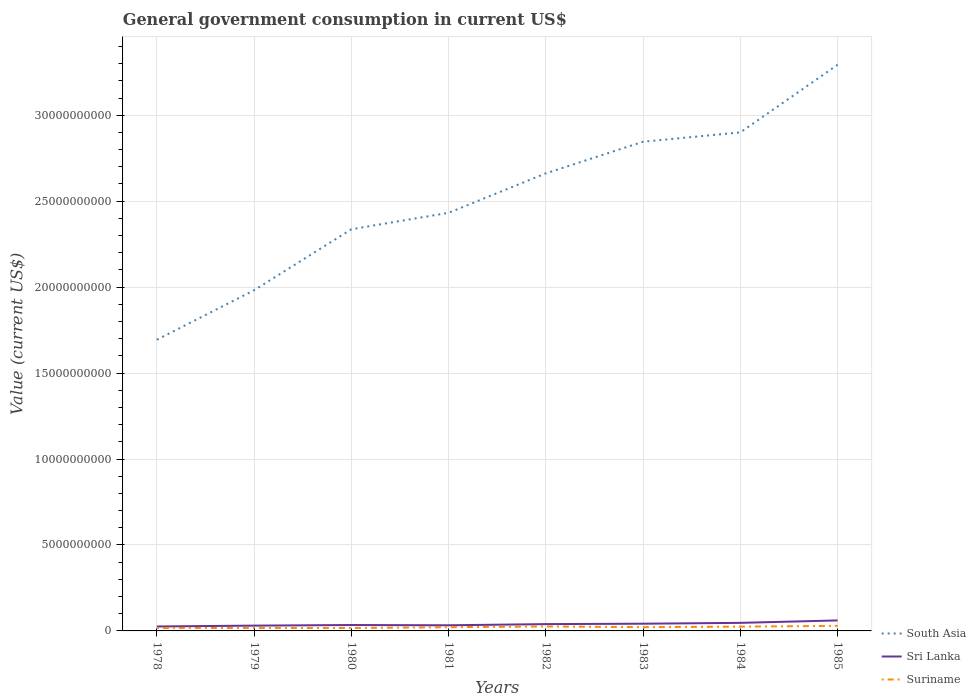How many different coloured lines are there?
Offer a terse response. 3. Does the line corresponding to Sri Lanka intersect with the line corresponding to South Asia?
Offer a terse response. No. Is the number of lines equal to the number of legend labels?
Ensure brevity in your answer.  Yes. Across all years, what is the maximum government conusmption in Suriname?
Your answer should be very brief. 1.68e+08. In which year was the government conusmption in Sri Lanka maximum?
Provide a succinct answer. 1978. What is the total government conusmption in Sri Lanka in the graph?
Provide a succinct answer. -1.96e+07. What is the difference between the highest and the second highest government conusmption in Suriname?
Your answer should be compact. 1.27e+08. How many lines are there?
Ensure brevity in your answer.  3. How many years are there in the graph?
Provide a succinct answer. 8. What is the difference between two consecutive major ticks on the Y-axis?
Give a very brief answer. 5.00e+09. Where does the legend appear in the graph?
Provide a succinct answer. Bottom right. How are the legend labels stacked?
Offer a very short reply. Vertical. What is the title of the graph?
Provide a succinct answer. General government consumption in current US$. Does "Benin" appear as one of the legend labels in the graph?
Offer a very short reply. No. What is the label or title of the Y-axis?
Offer a terse response. Value (current US$). What is the Value (current US$) of South Asia in 1978?
Provide a short and direct response. 1.69e+1. What is the Value (current US$) in Sri Lanka in 1978?
Your answer should be compact. 2.59e+08. What is the Value (current US$) in Suriname in 1978?
Offer a very short reply. 1.68e+08. What is the Value (current US$) in South Asia in 1979?
Make the answer very short. 1.98e+1. What is the Value (current US$) of Sri Lanka in 1979?
Give a very brief answer. 3.08e+08. What is the Value (current US$) in Suriname in 1979?
Offer a terse response. 1.72e+08. What is the Value (current US$) of South Asia in 1980?
Make the answer very short. 2.34e+1. What is the Value (current US$) of Sri Lanka in 1980?
Provide a succinct answer. 3.44e+08. What is the Value (current US$) in Suriname in 1980?
Your response must be concise. 1.70e+08. What is the Value (current US$) of South Asia in 1981?
Offer a very short reply. 2.43e+1. What is the Value (current US$) in Sri Lanka in 1981?
Make the answer very short. 3.28e+08. What is the Value (current US$) of Suriname in 1981?
Keep it short and to the point. 2.16e+08. What is the Value (current US$) in South Asia in 1982?
Your answer should be compact. 2.66e+1. What is the Value (current US$) of Sri Lanka in 1982?
Provide a short and direct response. 3.96e+08. What is the Value (current US$) in Suriname in 1982?
Offer a terse response. 2.60e+08. What is the Value (current US$) of South Asia in 1983?
Ensure brevity in your answer.  2.85e+1. What is the Value (current US$) in Sri Lanka in 1983?
Offer a very short reply. 4.20e+08. What is the Value (current US$) of Suriname in 1983?
Make the answer very short. 2.19e+08. What is the Value (current US$) in South Asia in 1984?
Give a very brief answer. 2.90e+1. What is the Value (current US$) in Sri Lanka in 1984?
Offer a very short reply. 4.69e+08. What is the Value (current US$) in Suriname in 1984?
Make the answer very short. 2.49e+08. What is the Value (current US$) in South Asia in 1985?
Offer a very short reply. 3.29e+1. What is the Value (current US$) in Sri Lanka in 1985?
Offer a terse response. 6.11e+08. What is the Value (current US$) of Suriname in 1985?
Make the answer very short. 2.94e+08. Across all years, what is the maximum Value (current US$) in South Asia?
Ensure brevity in your answer.  3.29e+1. Across all years, what is the maximum Value (current US$) in Sri Lanka?
Give a very brief answer. 6.11e+08. Across all years, what is the maximum Value (current US$) in Suriname?
Your answer should be compact. 2.94e+08. Across all years, what is the minimum Value (current US$) of South Asia?
Ensure brevity in your answer.  1.69e+1. Across all years, what is the minimum Value (current US$) in Sri Lanka?
Your answer should be very brief. 2.59e+08. Across all years, what is the minimum Value (current US$) in Suriname?
Offer a terse response. 1.68e+08. What is the total Value (current US$) in South Asia in the graph?
Your response must be concise. 2.01e+11. What is the total Value (current US$) of Sri Lanka in the graph?
Your answer should be very brief. 3.14e+09. What is the total Value (current US$) in Suriname in the graph?
Offer a terse response. 1.75e+09. What is the difference between the Value (current US$) in South Asia in 1978 and that in 1979?
Offer a terse response. -2.88e+09. What is the difference between the Value (current US$) of Sri Lanka in 1978 and that in 1979?
Your response must be concise. -4.92e+07. What is the difference between the Value (current US$) in Suriname in 1978 and that in 1979?
Make the answer very short. -4.00e+06. What is the difference between the Value (current US$) in South Asia in 1978 and that in 1980?
Provide a succinct answer. -6.43e+09. What is the difference between the Value (current US$) of Sri Lanka in 1978 and that in 1980?
Keep it short and to the point. -8.49e+07. What is the difference between the Value (current US$) in Suriname in 1978 and that in 1980?
Keep it short and to the point. -2.00e+06. What is the difference between the Value (current US$) in South Asia in 1978 and that in 1981?
Offer a terse response. -7.38e+09. What is the difference between the Value (current US$) in Sri Lanka in 1978 and that in 1981?
Your answer should be very brief. -6.88e+07. What is the difference between the Value (current US$) in Suriname in 1978 and that in 1981?
Provide a short and direct response. -4.80e+07. What is the difference between the Value (current US$) of South Asia in 1978 and that in 1982?
Provide a short and direct response. -9.68e+09. What is the difference between the Value (current US$) in Sri Lanka in 1978 and that in 1982?
Give a very brief answer. -1.37e+08. What is the difference between the Value (current US$) of Suriname in 1978 and that in 1982?
Your answer should be compact. -9.25e+07. What is the difference between the Value (current US$) in South Asia in 1978 and that in 1983?
Offer a very short reply. -1.15e+1. What is the difference between the Value (current US$) of Sri Lanka in 1978 and that in 1983?
Ensure brevity in your answer.  -1.61e+08. What is the difference between the Value (current US$) of Suriname in 1978 and that in 1983?
Offer a very short reply. -5.11e+07. What is the difference between the Value (current US$) of South Asia in 1978 and that in 1984?
Your answer should be compact. -1.21e+1. What is the difference between the Value (current US$) of Sri Lanka in 1978 and that in 1984?
Provide a succinct answer. -2.10e+08. What is the difference between the Value (current US$) of Suriname in 1978 and that in 1984?
Make the answer very short. -8.19e+07. What is the difference between the Value (current US$) of South Asia in 1978 and that in 1985?
Provide a short and direct response. -1.60e+1. What is the difference between the Value (current US$) in Sri Lanka in 1978 and that in 1985?
Your answer should be compact. -3.52e+08. What is the difference between the Value (current US$) in Suriname in 1978 and that in 1985?
Ensure brevity in your answer.  -1.27e+08. What is the difference between the Value (current US$) of South Asia in 1979 and that in 1980?
Offer a terse response. -3.55e+09. What is the difference between the Value (current US$) of Sri Lanka in 1979 and that in 1980?
Ensure brevity in your answer.  -3.58e+07. What is the difference between the Value (current US$) of South Asia in 1979 and that in 1981?
Keep it short and to the point. -4.50e+09. What is the difference between the Value (current US$) of Sri Lanka in 1979 and that in 1981?
Make the answer very short. -1.96e+07. What is the difference between the Value (current US$) of Suriname in 1979 and that in 1981?
Make the answer very short. -4.40e+07. What is the difference between the Value (current US$) of South Asia in 1979 and that in 1982?
Your answer should be very brief. -6.80e+09. What is the difference between the Value (current US$) of Sri Lanka in 1979 and that in 1982?
Keep it short and to the point. -8.79e+07. What is the difference between the Value (current US$) in Suriname in 1979 and that in 1982?
Give a very brief answer. -8.85e+07. What is the difference between the Value (current US$) in South Asia in 1979 and that in 1983?
Give a very brief answer. -8.64e+09. What is the difference between the Value (current US$) in Sri Lanka in 1979 and that in 1983?
Offer a very short reply. -1.12e+08. What is the difference between the Value (current US$) of Suriname in 1979 and that in 1983?
Keep it short and to the point. -4.71e+07. What is the difference between the Value (current US$) in South Asia in 1979 and that in 1984?
Your response must be concise. -9.18e+09. What is the difference between the Value (current US$) in Sri Lanka in 1979 and that in 1984?
Make the answer very short. -1.61e+08. What is the difference between the Value (current US$) of Suriname in 1979 and that in 1984?
Your answer should be compact. -7.79e+07. What is the difference between the Value (current US$) of South Asia in 1979 and that in 1985?
Your response must be concise. -1.31e+1. What is the difference between the Value (current US$) in Sri Lanka in 1979 and that in 1985?
Offer a terse response. -3.03e+08. What is the difference between the Value (current US$) of Suriname in 1979 and that in 1985?
Make the answer very short. -1.23e+08. What is the difference between the Value (current US$) in South Asia in 1980 and that in 1981?
Your response must be concise. -9.56e+08. What is the difference between the Value (current US$) in Sri Lanka in 1980 and that in 1981?
Provide a short and direct response. 1.61e+07. What is the difference between the Value (current US$) of Suriname in 1980 and that in 1981?
Ensure brevity in your answer.  -4.60e+07. What is the difference between the Value (current US$) of South Asia in 1980 and that in 1982?
Provide a short and direct response. -3.25e+09. What is the difference between the Value (current US$) of Sri Lanka in 1980 and that in 1982?
Offer a very short reply. -5.21e+07. What is the difference between the Value (current US$) in Suriname in 1980 and that in 1982?
Provide a short and direct response. -9.05e+07. What is the difference between the Value (current US$) in South Asia in 1980 and that in 1983?
Make the answer very short. -5.09e+09. What is the difference between the Value (current US$) in Sri Lanka in 1980 and that in 1983?
Your response must be concise. -7.64e+07. What is the difference between the Value (current US$) in Suriname in 1980 and that in 1983?
Your answer should be compact. -4.91e+07. What is the difference between the Value (current US$) in South Asia in 1980 and that in 1984?
Your answer should be very brief. -5.63e+09. What is the difference between the Value (current US$) in Sri Lanka in 1980 and that in 1984?
Keep it short and to the point. -1.25e+08. What is the difference between the Value (current US$) in Suriname in 1980 and that in 1984?
Your answer should be compact. -7.99e+07. What is the difference between the Value (current US$) in South Asia in 1980 and that in 1985?
Ensure brevity in your answer.  -9.57e+09. What is the difference between the Value (current US$) in Sri Lanka in 1980 and that in 1985?
Offer a terse response. -2.67e+08. What is the difference between the Value (current US$) of Suriname in 1980 and that in 1985?
Your answer should be very brief. -1.25e+08. What is the difference between the Value (current US$) in South Asia in 1981 and that in 1982?
Provide a succinct answer. -2.30e+09. What is the difference between the Value (current US$) in Sri Lanka in 1981 and that in 1982?
Give a very brief answer. -6.83e+07. What is the difference between the Value (current US$) in Suriname in 1981 and that in 1982?
Ensure brevity in your answer.  -4.45e+07. What is the difference between the Value (current US$) in South Asia in 1981 and that in 1983?
Give a very brief answer. -4.14e+09. What is the difference between the Value (current US$) in Sri Lanka in 1981 and that in 1983?
Your response must be concise. -9.25e+07. What is the difference between the Value (current US$) in Suriname in 1981 and that in 1983?
Your answer should be compact. -3.10e+06. What is the difference between the Value (current US$) of South Asia in 1981 and that in 1984?
Your answer should be compact. -4.68e+09. What is the difference between the Value (current US$) of Sri Lanka in 1981 and that in 1984?
Your response must be concise. -1.41e+08. What is the difference between the Value (current US$) of Suriname in 1981 and that in 1984?
Give a very brief answer. -3.39e+07. What is the difference between the Value (current US$) in South Asia in 1981 and that in 1985?
Your response must be concise. -8.61e+09. What is the difference between the Value (current US$) in Sri Lanka in 1981 and that in 1985?
Your response must be concise. -2.83e+08. What is the difference between the Value (current US$) of Suriname in 1981 and that in 1985?
Provide a short and direct response. -7.88e+07. What is the difference between the Value (current US$) in South Asia in 1982 and that in 1983?
Make the answer very short. -1.84e+09. What is the difference between the Value (current US$) of Sri Lanka in 1982 and that in 1983?
Provide a short and direct response. -2.42e+07. What is the difference between the Value (current US$) in Suriname in 1982 and that in 1983?
Your response must be concise. 4.14e+07. What is the difference between the Value (current US$) in South Asia in 1982 and that in 1984?
Give a very brief answer. -2.38e+09. What is the difference between the Value (current US$) in Sri Lanka in 1982 and that in 1984?
Your answer should be very brief. -7.31e+07. What is the difference between the Value (current US$) in Suriname in 1982 and that in 1984?
Make the answer very short. 1.06e+07. What is the difference between the Value (current US$) of South Asia in 1982 and that in 1985?
Your response must be concise. -6.32e+09. What is the difference between the Value (current US$) in Sri Lanka in 1982 and that in 1985?
Ensure brevity in your answer.  -2.15e+08. What is the difference between the Value (current US$) of Suriname in 1982 and that in 1985?
Your answer should be very brief. -3.42e+07. What is the difference between the Value (current US$) in South Asia in 1983 and that in 1984?
Your answer should be compact. -5.43e+08. What is the difference between the Value (current US$) in Sri Lanka in 1983 and that in 1984?
Your response must be concise. -4.89e+07. What is the difference between the Value (current US$) of Suriname in 1983 and that in 1984?
Make the answer very short. -3.08e+07. What is the difference between the Value (current US$) in South Asia in 1983 and that in 1985?
Your response must be concise. -4.48e+09. What is the difference between the Value (current US$) in Sri Lanka in 1983 and that in 1985?
Your response must be concise. -1.91e+08. What is the difference between the Value (current US$) in Suriname in 1983 and that in 1985?
Your answer should be compact. -7.56e+07. What is the difference between the Value (current US$) of South Asia in 1984 and that in 1985?
Provide a short and direct response. -3.93e+09. What is the difference between the Value (current US$) in Sri Lanka in 1984 and that in 1985?
Keep it short and to the point. -1.42e+08. What is the difference between the Value (current US$) in Suriname in 1984 and that in 1985?
Your answer should be compact. -4.48e+07. What is the difference between the Value (current US$) of South Asia in 1978 and the Value (current US$) of Sri Lanka in 1979?
Ensure brevity in your answer.  1.66e+1. What is the difference between the Value (current US$) in South Asia in 1978 and the Value (current US$) in Suriname in 1979?
Ensure brevity in your answer.  1.68e+1. What is the difference between the Value (current US$) of Sri Lanka in 1978 and the Value (current US$) of Suriname in 1979?
Provide a succinct answer. 8.75e+07. What is the difference between the Value (current US$) of South Asia in 1978 and the Value (current US$) of Sri Lanka in 1980?
Your answer should be compact. 1.66e+1. What is the difference between the Value (current US$) in South Asia in 1978 and the Value (current US$) in Suriname in 1980?
Offer a terse response. 1.68e+1. What is the difference between the Value (current US$) in Sri Lanka in 1978 and the Value (current US$) in Suriname in 1980?
Your answer should be compact. 8.95e+07. What is the difference between the Value (current US$) of South Asia in 1978 and the Value (current US$) of Sri Lanka in 1981?
Give a very brief answer. 1.66e+1. What is the difference between the Value (current US$) in South Asia in 1978 and the Value (current US$) in Suriname in 1981?
Your answer should be compact. 1.67e+1. What is the difference between the Value (current US$) of Sri Lanka in 1978 and the Value (current US$) of Suriname in 1981?
Keep it short and to the point. 4.35e+07. What is the difference between the Value (current US$) in South Asia in 1978 and the Value (current US$) in Sri Lanka in 1982?
Your answer should be compact. 1.65e+1. What is the difference between the Value (current US$) of South Asia in 1978 and the Value (current US$) of Suriname in 1982?
Provide a short and direct response. 1.67e+1. What is the difference between the Value (current US$) in Sri Lanka in 1978 and the Value (current US$) in Suriname in 1982?
Your response must be concise. -9.99e+05. What is the difference between the Value (current US$) of South Asia in 1978 and the Value (current US$) of Sri Lanka in 1983?
Offer a very short reply. 1.65e+1. What is the difference between the Value (current US$) of South Asia in 1978 and the Value (current US$) of Suriname in 1983?
Ensure brevity in your answer.  1.67e+1. What is the difference between the Value (current US$) of Sri Lanka in 1978 and the Value (current US$) of Suriname in 1983?
Offer a very short reply. 4.04e+07. What is the difference between the Value (current US$) in South Asia in 1978 and the Value (current US$) in Sri Lanka in 1984?
Your response must be concise. 1.65e+1. What is the difference between the Value (current US$) of South Asia in 1978 and the Value (current US$) of Suriname in 1984?
Provide a short and direct response. 1.67e+1. What is the difference between the Value (current US$) of Sri Lanka in 1978 and the Value (current US$) of Suriname in 1984?
Provide a succinct answer. 9.60e+06. What is the difference between the Value (current US$) of South Asia in 1978 and the Value (current US$) of Sri Lanka in 1985?
Provide a short and direct response. 1.63e+1. What is the difference between the Value (current US$) of South Asia in 1978 and the Value (current US$) of Suriname in 1985?
Make the answer very short. 1.66e+1. What is the difference between the Value (current US$) in Sri Lanka in 1978 and the Value (current US$) in Suriname in 1985?
Your response must be concise. -3.52e+07. What is the difference between the Value (current US$) of South Asia in 1979 and the Value (current US$) of Sri Lanka in 1980?
Make the answer very short. 1.95e+1. What is the difference between the Value (current US$) of South Asia in 1979 and the Value (current US$) of Suriname in 1980?
Your answer should be very brief. 1.97e+1. What is the difference between the Value (current US$) in Sri Lanka in 1979 and the Value (current US$) in Suriname in 1980?
Make the answer very short. 1.39e+08. What is the difference between the Value (current US$) of South Asia in 1979 and the Value (current US$) of Sri Lanka in 1981?
Your answer should be very brief. 1.95e+1. What is the difference between the Value (current US$) of South Asia in 1979 and the Value (current US$) of Suriname in 1981?
Give a very brief answer. 1.96e+1. What is the difference between the Value (current US$) in Sri Lanka in 1979 and the Value (current US$) in Suriname in 1981?
Your answer should be very brief. 9.27e+07. What is the difference between the Value (current US$) of South Asia in 1979 and the Value (current US$) of Sri Lanka in 1982?
Give a very brief answer. 1.94e+1. What is the difference between the Value (current US$) of South Asia in 1979 and the Value (current US$) of Suriname in 1982?
Ensure brevity in your answer.  1.96e+1. What is the difference between the Value (current US$) of Sri Lanka in 1979 and the Value (current US$) of Suriname in 1982?
Make the answer very short. 4.82e+07. What is the difference between the Value (current US$) in South Asia in 1979 and the Value (current US$) in Sri Lanka in 1983?
Keep it short and to the point. 1.94e+1. What is the difference between the Value (current US$) of South Asia in 1979 and the Value (current US$) of Suriname in 1983?
Make the answer very short. 1.96e+1. What is the difference between the Value (current US$) in Sri Lanka in 1979 and the Value (current US$) in Suriname in 1983?
Your answer should be compact. 8.96e+07. What is the difference between the Value (current US$) of South Asia in 1979 and the Value (current US$) of Sri Lanka in 1984?
Keep it short and to the point. 1.94e+1. What is the difference between the Value (current US$) in South Asia in 1979 and the Value (current US$) in Suriname in 1984?
Your answer should be very brief. 1.96e+1. What is the difference between the Value (current US$) of Sri Lanka in 1979 and the Value (current US$) of Suriname in 1984?
Offer a terse response. 5.88e+07. What is the difference between the Value (current US$) in South Asia in 1979 and the Value (current US$) in Sri Lanka in 1985?
Make the answer very short. 1.92e+1. What is the difference between the Value (current US$) of South Asia in 1979 and the Value (current US$) of Suriname in 1985?
Give a very brief answer. 1.95e+1. What is the difference between the Value (current US$) in Sri Lanka in 1979 and the Value (current US$) in Suriname in 1985?
Your answer should be compact. 1.39e+07. What is the difference between the Value (current US$) of South Asia in 1980 and the Value (current US$) of Sri Lanka in 1981?
Your answer should be compact. 2.30e+1. What is the difference between the Value (current US$) in South Asia in 1980 and the Value (current US$) in Suriname in 1981?
Keep it short and to the point. 2.32e+1. What is the difference between the Value (current US$) of Sri Lanka in 1980 and the Value (current US$) of Suriname in 1981?
Give a very brief answer. 1.28e+08. What is the difference between the Value (current US$) in South Asia in 1980 and the Value (current US$) in Sri Lanka in 1982?
Ensure brevity in your answer.  2.30e+1. What is the difference between the Value (current US$) in South Asia in 1980 and the Value (current US$) in Suriname in 1982?
Your response must be concise. 2.31e+1. What is the difference between the Value (current US$) in Sri Lanka in 1980 and the Value (current US$) in Suriname in 1982?
Make the answer very short. 8.39e+07. What is the difference between the Value (current US$) in South Asia in 1980 and the Value (current US$) in Sri Lanka in 1983?
Keep it short and to the point. 2.29e+1. What is the difference between the Value (current US$) of South Asia in 1980 and the Value (current US$) of Suriname in 1983?
Your answer should be very brief. 2.31e+1. What is the difference between the Value (current US$) in Sri Lanka in 1980 and the Value (current US$) in Suriname in 1983?
Give a very brief answer. 1.25e+08. What is the difference between the Value (current US$) in South Asia in 1980 and the Value (current US$) in Sri Lanka in 1984?
Your answer should be compact. 2.29e+1. What is the difference between the Value (current US$) in South Asia in 1980 and the Value (current US$) in Suriname in 1984?
Your answer should be compact. 2.31e+1. What is the difference between the Value (current US$) of Sri Lanka in 1980 and the Value (current US$) of Suriname in 1984?
Your answer should be very brief. 9.45e+07. What is the difference between the Value (current US$) in South Asia in 1980 and the Value (current US$) in Sri Lanka in 1985?
Offer a terse response. 2.28e+1. What is the difference between the Value (current US$) of South Asia in 1980 and the Value (current US$) of Suriname in 1985?
Give a very brief answer. 2.31e+1. What is the difference between the Value (current US$) of Sri Lanka in 1980 and the Value (current US$) of Suriname in 1985?
Make the answer very short. 4.97e+07. What is the difference between the Value (current US$) of South Asia in 1981 and the Value (current US$) of Sri Lanka in 1982?
Your answer should be very brief. 2.39e+1. What is the difference between the Value (current US$) in South Asia in 1981 and the Value (current US$) in Suriname in 1982?
Offer a terse response. 2.41e+1. What is the difference between the Value (current US$) of Sri Lanka in 1981 and the Value (current US$) of Suriname in 1982?
Your response must be concise. 6.78e+07. What is the difference between the Value (current US$) of South Asia in 1981 and the Value (current US$) of Sri Lanka in 1983?
Your answer should be very brief. 2.39e+1. What is the difference between the Value (current US$) in South Asia in 1981 and the Value (current US$) in Suriname in 1983?
Keep it short and to the point. 2.41e+1. What is the difference between the Value (current US$) in Sri Lanka in 1981 and the Value (current US$) in Suriname in 1983?
Provide a succinct answer. 1.09e+08. What is the difference between the Value (current US$) in South Asia in 1981 and the Value (current US$) in Sri Lanka in 1984?
Offer a very short reply. 2.39e+1. What is the difference between the Value (current US$) of South Asia in 1981 and the Value (current US$) of Suriname in 1984?
Your response must be concise. 2.41e+1. What is the difference between the Value (current US$) in Sri Lanka in 1981 and the Value (current US$) in Suriname in 1984?
Provide a succinct answer. 7.84e+07. What is the difference between the Value (current US$) in South Asia in 1981 and the Value (current US$) in Sri Lanka in 1985?
Keep it short and to the point. 2.37e+1. What is the difference between the Value (current US$) in South Asia in 1981 and the Value (current US$) in Suriname in 1985?
Ensure brevity in your answer.  2.40e+1. What is the difference between the Value (current US$) in Sri Lanka in 1981 and the Value (current US$) in Suriname in 1985?
Ensure brevity in your answer.  3.35e+07. What is the difference between the Value (current US$) in South Asia in 1982 and the Value (current US$) in Sri Lanka in 1983?
Provide a short and direct response. 2.62e+1. What is the difference between the Value (current US$) of South Asia in 1982 and the Value (current US$) of Suriname in 1983?
Offer a terse response. 2.64e+1. What is the difference between the Value (current US$) in Sri Lanka in 1982 and the Value (current US$) in Suriname in 1983?
Provide a short and direct response. 1.77e+08. What is the difference between the Value (current US$) of South Asia in 1982 and the Value (current US$) of Sri Lanka in 1984?
Your answer should be very brief. 2.61e+1. What is the difference between the Value (current US$) of South Asia in 1982 and the Value (current US$) of Suriname in 1984?
Provide a short and direct response. 2.64e+1. What is the difference between the Value (current US$) in Sri Lanka in 1982 and the Value (current US$) in Suriname in 1984?
Offer a very short reply. 1.47e+08. What is the difference between the Value (current US$) of South Asia in 1982 and the Value (current US$) of Sri Lanka in 1985?
Offer a terse response. 2.60e+1. What is the difference between the Value (current US$) in South Asia in 1982 and the Value (current US$) in Suriname in 1985?
Give a very brief answer. 2.63e+1. What is the difference between the Value (current US$) of Sri Lanka in 1982 and the Value (current US$) of Suriname in 1985?
Your answer should be very brief. 1.02e+08. What is the difference between the Value (current US$) of South Asia in 1983 and the Value (current US$) of Sri Lanka in 1984?
Your response must be concise. 2.80e+1. What is the difference between the Value (current US$) in South Asia in 1983 and the Value (current US$) in Suriname in 1984?
Provide a short and direct response. 2.82e+1. What is the difference between the Value (current US$) in Sri Lanka in 1983 and the Value (current US$) in Suriname in 1984?
Keep it short and to the point. 1.71e+08. What is the difference between the Value (current US$) of South Asia in 1983 and the Value (current US$) of Sri Lanka in 1985?
Make the answer very short. 2.78e+1. What is the difference between the Value (current US$) of South Asia in 1983 and the Value (current US$) of Suriname in 1985?
Your answer should be compact. 2.82e+1. What is the difference between the Value (current US$) of Sri Lanka in 1983 and the Value (current US$) of Suriname in 1985?
Provide a short and direct response. 1.26e+08. What is the difference between the Value (current US$) of South Asia in 1984 and the Value (current US$) of Sri Lanka in 1985?
Your response must be concise. 2.84e+1. What is the difference between the Value (current US$) of South Asia in 1984 and the Value (current US$) of Suriname in 1985?
Your answer should be compact. 2.87e+1. What is the difference between the Value (current US$) in Sri Lanka in 1984 and the Value (current US$) in Suriname in 1985?
Your answer should be compact. 1.75e+08. What is the average Value (current US$) in South Asia per year?
Offer a terse response. 2.52e+1. What is the average Value (current US$) of Sri Lanka per year?
Offer a terse response. 3.92e+08. What is the average Value (current US$) of Suriname per year?
Your answer should be very brief. 2.18e+08. In the year 1978, what is the difference between the Value (current US$) in South Asia and Value (current US$) in Sri Lanka?
Provide a short and direct response. 1.67e+1. In the year 1978, what is the difference between the Value (current US$) of South Asia and Value (current US$) of Suriname?
Provide a succinct answer. 1.68e+1. In the year 1978, what is the difference between the Value (current US$) in Sri Lanka and Value (current US$) in Suriname?
Provide a succinct answer. 9.15e+07. In the year 1979, what is the difference between the Value (current US$) in South Asia and Value (current US$) in Sri Lanka?
Provide a succinct answer. 1.95e+1. In the year 1979, what is the difference between the Value (current US$) in South Asia and Value (current US$) in Suriname?
Your response must be concise. 1.96e+1. In the year 1979, what is the difference between the Value (current US$) of Sri Lanka and Value (current US$) of Suriname?
Your answer should be compact. 1.37e+08. In the year 1980, what is the difference between the Value (current US$) of South Asia and Value (current US$) of Sri Lanka?
Provide a short and direct response. 2.30e+1. In the year 1980, what is the difference between the Value (current US$) of South Asia and Value (current US$) of Suriname?
Make the answer very short. 2.32e+1. In the year 1980, what is the difference between the Value (current US$) in Sri Lanka and Value (current US$) in Suriname?
Keep it short and to the point. 1.74e+08. In the year 1981, what is the difference between the Value (current US$) in South Asia and Value (current US$) in Sri Lanka?
Provide a short and direct response. 2.40e+1. In the year 1981, what is the difference between the Value (current US$) of South Asia and Value (current US$) of Suriname?
Provide a succinct answer. 2.41e+1. In the year 1981, what is the difference between the Value (current US$) in Sri Lanka and Value (current US$) in Suriname?
Your answer should be very brief. 1.12e+08. In the year 1982, what is the difference between the Value (current US$) of South Asia and Value (current US$) of Sri Lanka?
Make the answer very short. 2.62e+1. In the year 1982, what is the difference between the Value (current US$) in South Asia and Value (current US$) in Suriname?
Offer a very short reply. 2.64e+1. In the year 1982, what is the difference between the Value (current US$) in Sri Lanka and Value (current US$) in Suriname?
Give a very brief answer. 1.36e+08. In the year 1983, what is the difference between the Value (current US$) in South Asia and Value (current US$) in Sri Lanka?
Your answer should be very brief. 2.80e+1. In the year 1983, what is the difference between the Value (current US$) of South Asia and Value (current US$) of Suriname?
Ensure brevity in your answer.  2.82e+1. In the year 1983, what is the difference between the Value (current US$) of Sri Lanka and Value (current US$) of Suriname?
Your response must be concise. 2.02e+08. In the year 1984, what is the difference between the Value (current US$) in South Asia and Value (current US$) in Sri Lanka?
Give a very brief answer. 2.85e+1. In the year 1984, what is the difference between the Value (current US$) in South Asia and Value (current US$) in Suriname?
Provide a succinct answer. 2.88e+1. In the year 1984, what is the difference between the Value (current US$) in Sri Lanka and Value (current US$) in Suriname?
Your answer should be compact. 2.20e+08. In the year 1985, what is the difference between the Value (current US$) of South Asia and Value (current US$) of Sri Lanka?
Keep it short and to the point. 3.23e+1. In the year 1985, what is the difference between the Value (current US$) of South Asia and Value (current US$) of Suriname?
Offer a terse response. 3.26e+1. In the year 1985, what is the difference between the Value (current US$) in Sri Lanka and Value (current US$) in Suriname?
Keep it short and to the point. 3.17e+08. What is the ratio of the Value (current US$) of South Asia in 1978 to that in 1979?
Make the answer very short. 0.85. What is the ratio of the Value (current US$) in Sri Lanka in 1978 to that in 1979?
Your answer should be very brief. 0.84. What is the ratio of the Value (current US$) in Suriname in 1978 to that in 1979?
Your answer should be compact. 0.98. What is the ratio of the Value (current US$) of South Asia in 1978 to that in 1980?
Provide a short and direct response. 0.72. What is the ratio of the Value (current US$) in Sri Lanka in 1978 to that in 1980?
Make the answer very short. 0.75. What is the ratio of the Value (current US$) of South Asia in 1978 to that in 1981?
Give a very brief answer. 0.7. What is the ratio of the Value (current US$) in Sri Lanka in 1978 to that in 1981?
Make the answer very short. 0.79. What is the ratio of the Value (current US$) in Suriname in 1978 to that in 1981?
Make the answer very short. 0.78. What is the ratio of the Value (current US$) in South Asia in 1978 to that in 1982?
Give a very brief answer. 0.64. What is the ratio of the Value (current US$) of Sri Lanka in 1978 to that in 1982?
Ensure brevity in your answer.  0.65. What is the ratio of the Value (current US$) in Suriname in 1978 to that in 1982?
Ensure brevity in your answer.  0.64. What is the ratio of the Value (current US$) in South Asia in 1978 to that in 1983?
Provide a short and direct response. 0.6. What is the ratio of the Value (current US$) of Sri Lanka in 1978 to that in 1983?
Ensure brevity in your answer.  0.62. What is the ratio of the Value (current US$) in Suriname in 1978 to that in 1983?
Make the answer very short. 0.77. What is the ratio of the Value (current US$) of South Asia in 1978 to that in 1984?
Offer a terse response. 0.58. What is the ratio of the Value (current US$) in Sri Lanka in 1978 to that in 1984?
Your answer should be very brief. 0.55. What is the ratio of the Value (current US$) of Suriname in 1978 to that in 1984?
Your answer should be compact. 0.67. What is the ratio of the Value (current US$) of South Asia in 1978 to that in 1985?
Your answer should be very brief. 0.51. What is the ratio of the Value (current US$) of Sri Lanka in 1978 to that in 1985?
Your answer should be compact. 0.42. What is the ratio of the Value (current US$) of Suriname in 1978 to that in 1985?
Your answer should be very brief. 0.57. What is the ratio of the Value (current US$) in South Asia in 1979 to that in 1980?
Your answer should be very brief. 0.85. What is the ratio of the Value (current US$) of Sri Lanka in 1979 to that in 1980?
Your response must be concise. 0.9. What is the ratio of the Value (current US$) in Suriname in 1979 to that in 1980?
Your answer should be very brief. 1.01. What is the ratio of the Value (current US$) in South Asia in 1979 to that in 1981?
Provide a succinct answer. 0.81. What is the ratio of the Value (current US$) of Sri Lanka in 1979 to that in 1981?
Your response must be concise. 0.94. What is the ratio of the Value (current US$) of Suriname in 1979 to that in 1981?
Keep it short and to the point. 0.8. What is the ratio of the Value (current US$) of South Asia in 1979 to that in 1982?
Provide a succinct answer. 0.74. What is the ratio of the Value (current US$) of Sri Lanka in 1979 to that in 1982?
Your response must be concise. 0.78. What is the ratio of the Value (current US$) in Suriname in 1979 to that in 1982?
Your answer should be compact. 0.66. What is the ratio of the Value (current US$) in South Asia in 1979 to that in 1983?
Provide a succinct answer. 0.7. What is the ratio of the Value (current US$) of Sri Lanka in 1979 to that in 1983?
Provide a short and direct response. 0.73. What is the ratio of the Value (current US$) of Suriname in 1979 to that in 1983?
Make the answer very short. 0.78. What is the ratio of the Value (current US$) in South Asia in 1979 to that in 1984?
Your response must be concise. 0.68. What is the ratio of the Value (current US$) of Sri Lanka in 1979 to that in 1984?
Make the answer very short. 0.66. What is the ratio of the Value (current US$) of Suriname in 1979 to that in 1984?
Keep it short and to the point. 0.69. What is the ratio of the Value (current US$) of South Asia in 1979 to that in 1985?
Provide a short and direct response. 0.6. What is the ratio of the Value (current US$) of Sri Lanka in 1979 to that in 1985?
Ensure brevity in your answer.  0.5. What is the ratio of the Value (current US$) in Suriname in 1979 to that in 1985?
Offer a terse response. 0.58. What is the ratio of the Value (current US$) of South Asia in 1980 to that in 1981?
Keep it short and to the point. 0.96. What is the ratio of the Value (current US$) of Sri Lanka in 1980 to that in 1981?
Ensure brevity in your answer.  1.05. What is the ratio of the Value (current US$) in Suriname in 1980 to that in 1981?
Keep it short and to the point. 0.79. What is the ratio of the Value (current US$) in South Asia in 1980 to that in 1982?
Offer a very short reply. 0.88. What is the ratio of the Value (current US$) in Sri Lanka in 1980 to that in 1982?
Your answer should be compact. 0.87. What is the ratio of the Value (current US$) in Suriname in 1980 to that in 1982?
Make the answer very short. 0.65. What is the ratio of the Value (current US$) of South Asia in 1980 to that in 1983?
Give a very brief answer. 0.82. What is the ratio of the Value (current US$) of Sri Lanka in 1980 to that in 1983?
Your answer should be compact. 0.82. What is the ratio of the Value (current US$) in Suriname in 1980 to that in 1983?
Your answer should be very brief. 0.78. What is the ratio of the Value (current US$) of South Asia in 1980 to that in 1984?
Make the answer very short. 0.81. What is the ratio of the Value (current US$) of Sri Lanka in 1980 to that in 1984?
Make the answer very short. 0.73. What is the ratio of the Value (current US$) in Suriname in 1980 to that in 1984?
Give a very brief answer. 0.68. What is the ratio of the Value (current US$) in South Asia in 1980 to that in 1985?
Your answer should be compact. 0.71. What is the ratio of the Value (current US$) of Sri Lanka in 1980 to that in 1985?
Offer a terse response. 0.56. What is the ratio of the Value (current US$) of Suriname in 1980 to that in 1985?
Your response must be concise. 0.58. What is the ratio of the Value (current US$) in South Asia in 1981 to that in 1982?
Keep it short and to the point. 0.91. What is the ratio of the Value (current US$) of Sri Lanka in 1981 to that in 1982?
Provide a short and direct response. 0.83. What is the ratio of the Value (current US$) of Suriname in 1981 to that in 1982?
Provide a short and direct response. 0.83. What is the ratio of the Value (current US$) in South Asia in 1981 to that in 1983?
Provide a short and direct response. 0.85. What is the ratio of the Value (current US$) in Sri Lanka in 1981 to that in 1983?
Keep it short and to the point. 0.78. What is the ratio of the Value (current US$) of Suriname in 1981 to that in 1983?
Make the answer very short. 0.99. What is the ratio of the Value (current US$) of South Asia in 1981 to that in 1984?
Make the answer very short. 0.84. What is the ratio of the Value (current US$) in Sri Lanka in 1981 to that in 1984?
Keep it short and to the point. 0.7. What is the ratio of the Value (current US$) in Suriname in 1981 to that in 1984?
Provide a succinct answer. 0.86. What is the ratio of the Value (current US$) in South Asia in 1981 to that in 1985?
Offer a very short reply. 0.74. What is the ratio of the Value (current US$) of Sri Lanka in 1981 to that in 1985?
Make the answer very short. 0.54. What is the ratio of the Value (current US$) in Suriname in 1981 to that in 1985?
Give a very brief answer. 0.73. What is the ratio of the Value (current US$) in South Asia in 1982 to that in 1983?
Keep it short and to the point. 0.94. What is the ratio of the Value (current US$) in Sri Lanka in 1982 to that in 1983?
Offer a very short reply. 0.94. What is the ratio of the Value (current US$) in Suriname in 1982 to that in 1983?
Your answer should be compact. 1.19. What is the ratio of the Value (current US$) of South Asia in 1982 to that in 1984?
Your answer should be very brief. 0.92. What is the ratio of the Value (current US$) in Sri Lanka in 1982 to that in 1984?
Your response must be concise. 0.84. What is the ratio of the Value (current US$) in Suriname in 1982 to that in 1984?
Offer a very short reply. 1.04. What is the ratio of the Value (current US$) in South Asia in 1982 to that in 1985?
Your answer should be compact. 0.81. What is the ratio of the Value (current US$) of Sri Lanka in 1982 to that in 1985?
Your answer should be compact. 0.65. What is the ratio of the Value (current US$) of Suriname in 1982 to that in 1985?
Make the answer very short. 0.88. What is the ratio of the Value (current US$) in South Asia in 1983 to that in 1984?
Give a very brief answer. 0.98. What is the ratio of the Value (current US$) of Sri Lanka in 1983 to that in 1984?
Keep it short and to the point. 0.9. What is the ratio of the Value (current US$) in Suriname in 1983 to that in 1984?
Give a very brief answer. 0.88. What is the ratio of the Value (current US$) of South Asia in 1983 to that in 1985?
Offer a terse response. 0.86. What is the ratio of the Value (current US$) in Sri Lanka in 1983 to that in 1985?
Make the answer very short. 0.69. What is the ratio of the Value (current US$) of Suriname in 1983 to that in 1985?
Your answer should be very brief. 0.74. What is the ratio of the Value (current US$) of South Asia in 1984 to that in 1985?
Your answer should be compact. 0.88. What is the ratio of the Value (current US$) of Sri Lanka in 1984 to that in 1985?
Provide a short and direct response. 0.77. What is the ratio of the Value (current US$) of Suriname in 1984 to that in 1985?
Keep it short and to the point. 0.85. What is the difference between the highest and the second highest Value (current US$) in South Asia?
Provide a short and direct response. 3.93e+09. What is the difference between the highest and the second highest Value (current US$) of Sri Lanka?
Offer a very short reply. 1.42e+08. What is the difference between the highest and the second highest Value (current US$) in Suriname?
Your response must be concise. 3.42e+07. What is the difference between the highest and the lowest Value (current US$) of South Asia?
Provide a succinct answer. 1.60e+1. What is the difference between the highest and the lowest Value (current US$) in Sri Lanka?
Your answer should be compact. 3.52e+08. What is the difference between the highest and the lowest Value (current US$) of Suriname?
Keep it short and to the point. 1.27e+08. 